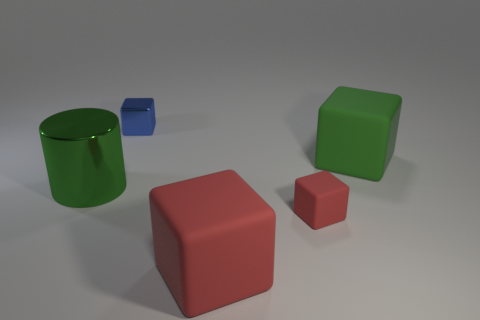Subtract all cyan cylinders. Subtract all cyan cubes. How many cylinders are left? 1 Add 3 tiny red matte cubes. How many objects exist? 8 Subtract all cubes. How many objects are left? 1 Subtract all small blue matte objects. Subtract all big green metallic cylinders. How many objects are left? 4 Add 1 tiny metallic things. How many tiny metallic things are left? 2 Add 5 green spheres. How many green spheres exist? 5 Subtract 0 blue spheres. How many objects are left? 5 